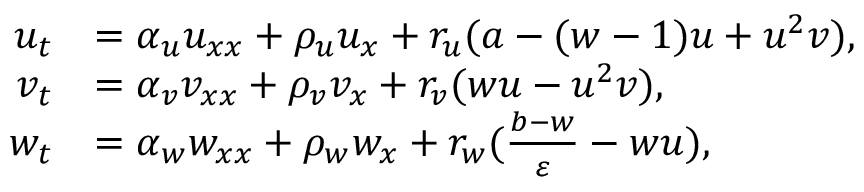<formula> <loc_0><loc_0><loc_500><loc_500>\begin{array} { r l } { u _ { t } } & { = \alpha _ { u } u _ { x x } + \rho _ { u } u _ { x } + r _ { u } ( a - ( w - 1 ) u + u ^ { 2 } v ) , } \\ { v _ { t } } & { = \alpha _ { v } v _ { x x } + \rho _ { v } v _ { x } + r _ { v } ( w u - u ^ { 2 } v ) , } \\ { w _ { t } } & { = \alpha _ { w } w _ { x x } + \rho _ { w } w _ { x } + r _ { w } ( \frac { b - w } { \varepsilon } - w u ) , } \end{array}</formula> 